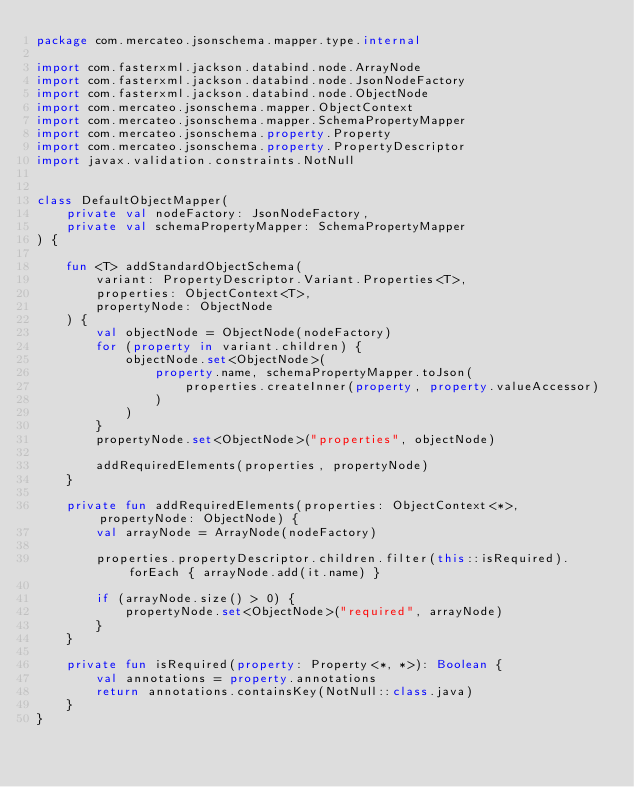Convert code to text. <code><loc_0><loc_0><loc_500><loc_500><_Kotlin_>package com.mercateo.jsonschema.mapper.type.internal

import com.fasterxml.jackson.databind.node.ArrayNode
import com.fasterxml.jackson.databind.node.JsonNodeFactory
import com.fasterxml.jackson.databind.node.ObjectNode
import com.mercateo.jsonschema.mapper.ObjectContext
import com.mercateo.jsonschema.mapper.SchemaPropertyMapper
import com.mercateo.jsonschema.property.Property
import com.mercateo.jsonschema.property.PropertyDescriptor
import javax.validation.constraints.NotNull


class DefaultObjectMapper(
    private val nodeFactory: JsonNodeFactory,
    private val schemaPropertyMapper: SchemaPropertyMapper
) {

    fun <T> addStandardObjectSchema(
        variant: PropertyDescriptor.Variant.Properties<T>,
        properties: ObjectContext<T>,
        propertyNode: ObjectNode
    ) {
        val objectNode = ObjectNode(nodeFactory)
        for (property in variant.children) {
            objectNode.set<ObjectNode>(
                property.name, schemaPropertyMapper.toJson(
                    properties.createInner(property, property.valueAccessor)
                )
            )
        }
        propertyNode.set<ObjectNode>("properties", objectNode)

        addRequiredElements(properties, propertyNode)
    }

    private fun addRequiredElements(properties: ObjectContext<*>, propertyNode: ObjectNode) {
        val arrayNode = ArrayNode(nodeFactory)

        properties.propertyDescriptor.children.filter(this::isRequired).forEach { arrayNode.add(it.name) }

        if (arrayNode.size() > 0) {
            propertyNode.set<ObjectNode>("required", arrayNode)
        }
    }

    private fun isRequired(property: Property<*, *>): Boolean {
        val annotations = property.annotations
        return annotations.containsKey(NotNull::class.java)
    }
}</code> 